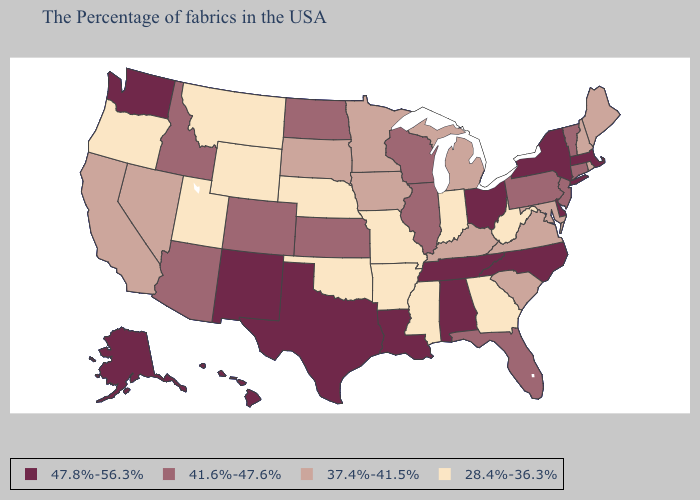Does Pennsylvania have the lowest value in the Northeast?
Write a very short answer. No. What is the value of Maryland?
Be succinct. 37.4%-41.5%. Which states have the lowest value in the USA?
Short answer required. West Virginia, Georgia, Indiana, Mississippi, Missouri, Arkansas, Nebraska, Oklahoma, Wyoming, Utah, Montana, Oregon. What is the lowest value in states that border New Hampshire?
Be succinct. 37.4%-41.5%. Which states have the lowest value in the USA?
Answer briefly. West Virginia, Georgia, Indiana, Mississippi, Missouri, Arkansas, Nebraska, Oklahoma, Wyoming, Utah, Montana, Oregon. Is the legend a continuous bar?
Be succinct. No. What is the value of North Dakota?
Concise answer only. 41.6%-47.6%. Does Texas have the lowest value in the South?
Give a very brief answer. No. Name the states that have a value in the range 37.4%-41.5%?
Quick response, please. Maine, Rhode Island, New Hampshire, Maryland, Virginia, South Carolina, Michigan, Kentucky, Minnesota, Iowa, South Dakota, Nevada, California. What is the highest value in the USA?
Write a very short answer. 47.8%-56.3%. Among the states that border Michigan , does Indiana have the lowest value?
Answer briefly. Yes. What is the value of Idaho?
Write a very short answer. 41.6%-47.6%. Which states have the lowest value in the West?
Give a very brief answer. Wyoming, Utah, Montana, Oregon. 